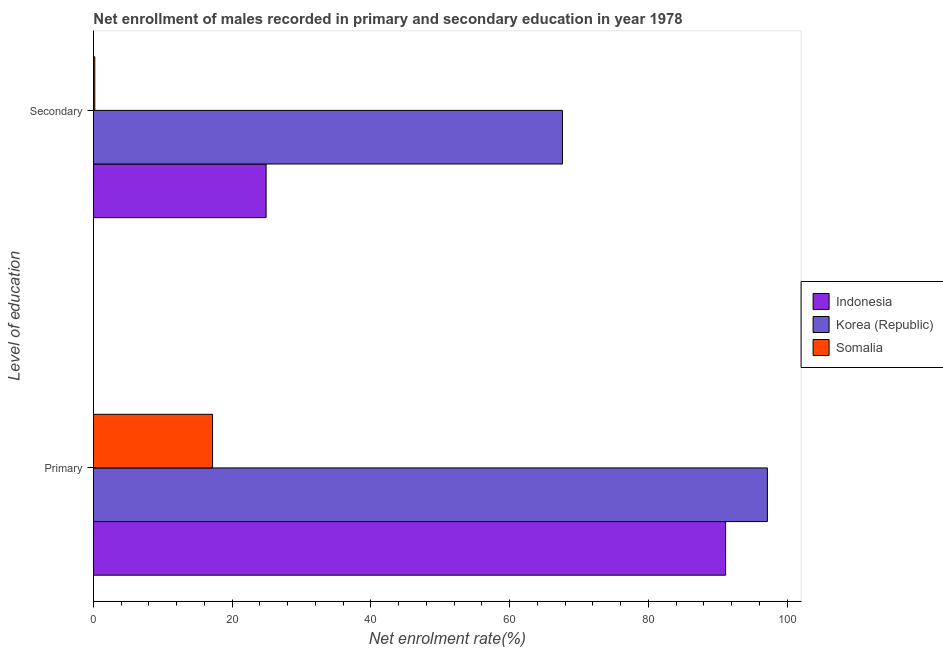How many different coloured bars are there?
Your answer should be compact. 3. How many groups of bars are there?
Give a very brief answer. 2. Are the number of bars per tick equal to the number of legend labels?
Your answer should be compact. Yes. Are the number of bars on each tick of the Y-axis equal?
Your answer should be very brief. Yes. How many bars are there on the 1st tick from the top?
Your answer should be very brief. 3. What is the label of the 2nd group of bars from the top?
Keep it short and to the point. Primary. What is the enrollment rate in secondary education in Somalia?
Make the answer very short. 0.19. Across all countries, what is the maximum enrollment rate in secondary education?
Your response must be concise. 67.61. Across all countries, what is the minimum enrollment rate in primary education?
Provide a short and direct response. 17.17. In which country was the enrollment rate in secondary education minimum?
Give a very brief answer. Somalia. What is the total enrollment rate in secondary education in the graph?
Your answer should be very brief. 92.69. What is the difference between the enrollment rate in primary education in Somalia and that in Indonesia?
Make the answer very short. -73.96. What is the difference between the enrollment rate in primary education in Indonesia and the enrollment rate in secondary education in Korea (Republic)?
Ensure brevity in your answer.  23.52. What is the average enrollment rate in secondary education per country?
Provide a short and direct response. 30.9. What is the difference between the enrollment rate in primary education and enrollment rate in secondary education in Somalia?
Ensure brevity in your answer.  16.98. What is the ratio of the enrollment rate in secondary education in Korea (Republic) to that in Somalia?
Offer a terse response. 355.93. In how many countries, is the enrollment rate in secondary education greater than the average enrollment rate in secondary education taken over all countries?
Give a very brief answer. 1. Are all the bars in the graph horizontal?
Make the answer very short. Yes. What is the title of the graph?
Give a very brief answer. Net enrollment of males recorded in primary and secondary education in year 1978. What is the label or title of the X-axis?
Offer a terse response. Net enrolment rate(%). What is the label or title of the Y-axis?
Provide a succinct answer. Level of education. What is the Net enrolment rate(%) in Indonesia in Primary?
Provide a short and direct response. 91.13. What is the Net enrolment rate(%) of Korea (Republic) in Primary?
Your response must be concise. 97.15. What is the Net enrolment rate(%) of Somalia in Primary?
Your response must be concise. 17.17. What is the Net enrolment rate(%) of Indonesia in Secondary?
Give a very brief answer. 24.89. What is the Net enrolment rate(%) in Korea (Republic) in Secondary?
Offer a very short reply. 67.61. What is the Net enrolment rate(%) in Somalia in Secondary?
Your response must be concise. 0.19. Across all Level of education, what is the maximum Net enrolment rate(%) in Indonesia?
Provide a short and direct response. 91.13. Across all Level of education, what is the maximum Net enrolment rate(%) of Korea (Republic)?
Ensure brevity in your answer.  97.15. Across all Level of education, what is the maximum Net enrolment rate(%) in Somalia?
Give a very brief answer. 17.17. Across all Level of education, what is the minimum Net enrolment rate(%) in Indonesia?
Offer a terse response. 24.89. Across all Level of education, what is the minimum Net enrolment rate(%) in Korea (Republic)?
Ensure brevity in your answer.  67.61. Across all Level of education, what is the minimum Net enrolment rate(%) in Somalia?
Offer a terse response. 0.19. What is the total Net enrolment rate(%) in Indonesia in the graph?
Offer a terse response. 116.02. What is the total Net enrolment rate(%) in Korea (Republic) in the graph?
Provide a succinct answer. 164.76. What is the total Net enrolment rate(%) of Somalia in the graph?
Ensure brevity in your answer.  17.36. What is the difference between the Net enrolment rate(%) of Indonesia in Primary and that in Secondary?
Provide a succinct answer. 66.24. What is the difference between the Net enrolment rate(%) of Korea (Republic) in Primary and that in Secondary?
Provide a succinct answer. 29.54. What is the difference between the Net enrolment rate(%) of Somalia in Primary and that in Secondary?
Give a very brief answer. 16.98. What is the difference between the Net enrolment rate(%) in Indonesia in Primary and the Net enrolment rate(%) in Korea (Republic) in Secondary?
Your answer should be compact. 23.52. What is the difference between the Net enrolment rate(%) of Indonesia in Primary and the Net enrolment rate(%) of Somalia in Secondary?
Make the answer very short. 90.94. What is the difference between the Net enrolment rate(%) in Korea (Republic) in Primary and the Net enrolment rate(%) in Somalia in Secondary?
Keep it short and to the point. 96.96. What is the average Net enrolment rate(%) of Indonesia per Level of education?
Offer a very short reply. 58.01. What is the average Net enrolment rate(%) of Korea (Republic) per Level of education?
Provide a short and direct response. 82.38. What is the average Net enrolment rate(%) in Somalia per Level of education?
Your answer should be compact. 8.68. What is the difference between the Net enrolment rate(%) in Indonesia and Net enrolment rate(%) in Korea (Republic) in Primary?
Keep it short and to the point. -6.02. What is the difference between the Net enrolment rate(%) in Indonesia and Net enrolment rate(%) in Somalia in Primary?
Provide a short and direct response. 73.96. What is the difference between the Net enrolment rate(%) in Korea (Republic) and Net enrolment rate(%) in Somalia in Primary?
Provide a succinct answer. 79.98. What is the difference between the Net enrolment rate(%) of Indonesia and Net enrolment rate(%) of Korea (Republic) in Secondary?
Give a very brief answer. -42.72. What is the difference between the Net enrolment rate(%) of Indonesia and Net enrolment rate(%) of Somalia in Secondary?
Offer a very short reply. 24.7. What is the difference between the Net enrolment rate(%) of Korea (Republic) and Net enrolment rate(%) of Somalia in Secondary?
Keep it short and to the point. 67.42. What is the ratio of the Net enrolment rate(%) of Indonesia in Primary to that in Secondary?
Your response must be concise. 3.66. What is the ratio of the Net enrolment rate(%) of Korea (Republic) in Primary to that in Secondary?
Your answer should be very brief. 1.44. What is the ratio of the Net enrolment rate(%) in Somalia in Primary to that in Secondary?
Offer a very short reply. 90.39. What is the difference between the highest and the second highest Net enrolment rate(%) of Indonesia?
Offer a very short reply. 66.24. What is the difference between the highest and the second highest Net enrolment rate(%) in Korea (Republic)?
Provide a succinct answer. 29.54. What is the difference between the highest and the second highest Net enrolment rate(%) in Somalia?
Your answer should be very brief. 16.98. What is the difference between the highest and the lowest Net enrolment rate(%) of Indonesia?
Give a very brief answer. 66.24. What is the difference between the highest and the lowest Net enrolment rate(%) in Korea (Republic)?
Provide a short and direct response. 29.54. What is the difference between the highest and the lowest Net enrolment rate(%) in Somalia?
Provide a short and direct response. 16.98. 